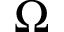Convert formula to latex. <formula><loc_0><loc_0><loc_500><loc_500>\Omega</formula> 